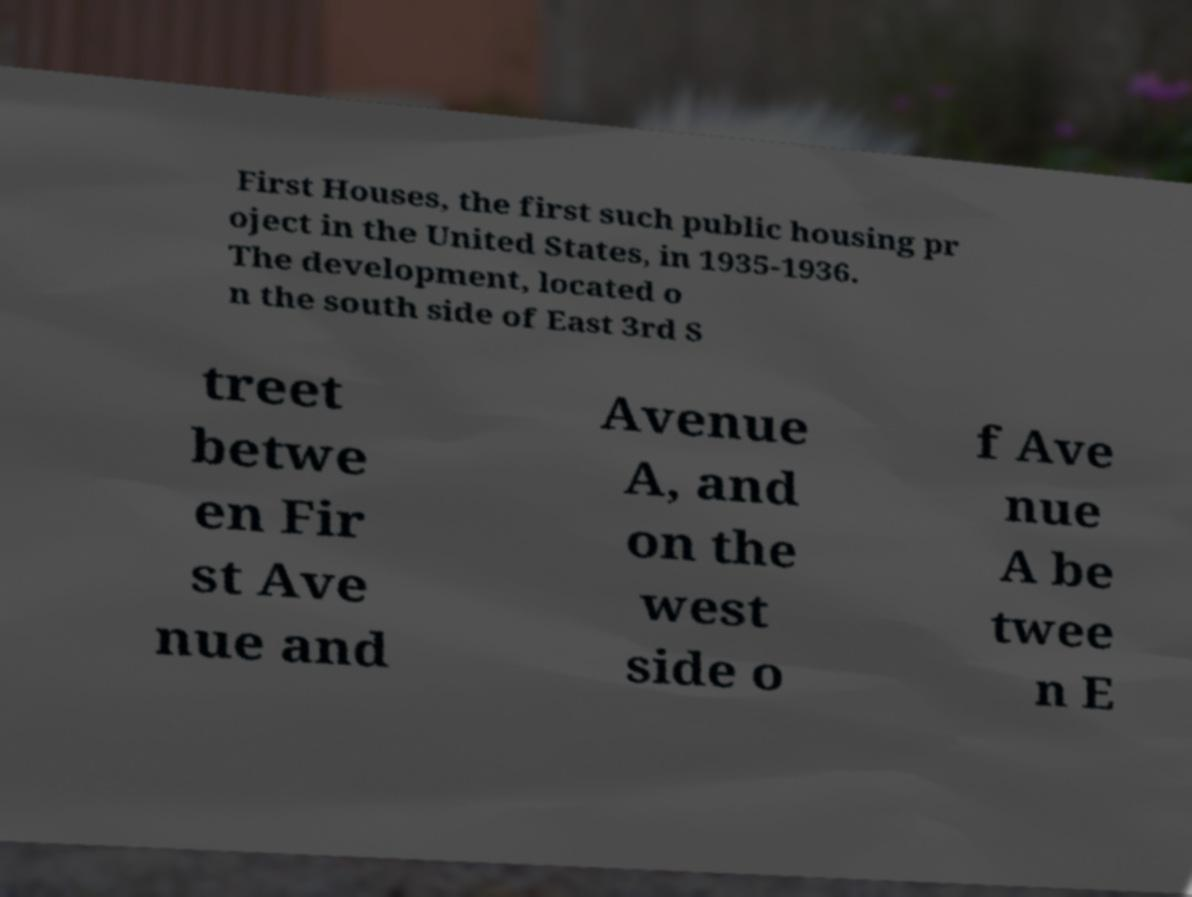Can you accurately transcribe the text from the provided image for me? First Houses, the first such public housing pr oject in the United States, in 1935-1936. The development, located o n the south side of East 3rd S treet betwe en Fir st Ave nue and Avenue A, and on the west side o f Ave nue A be twee n E 